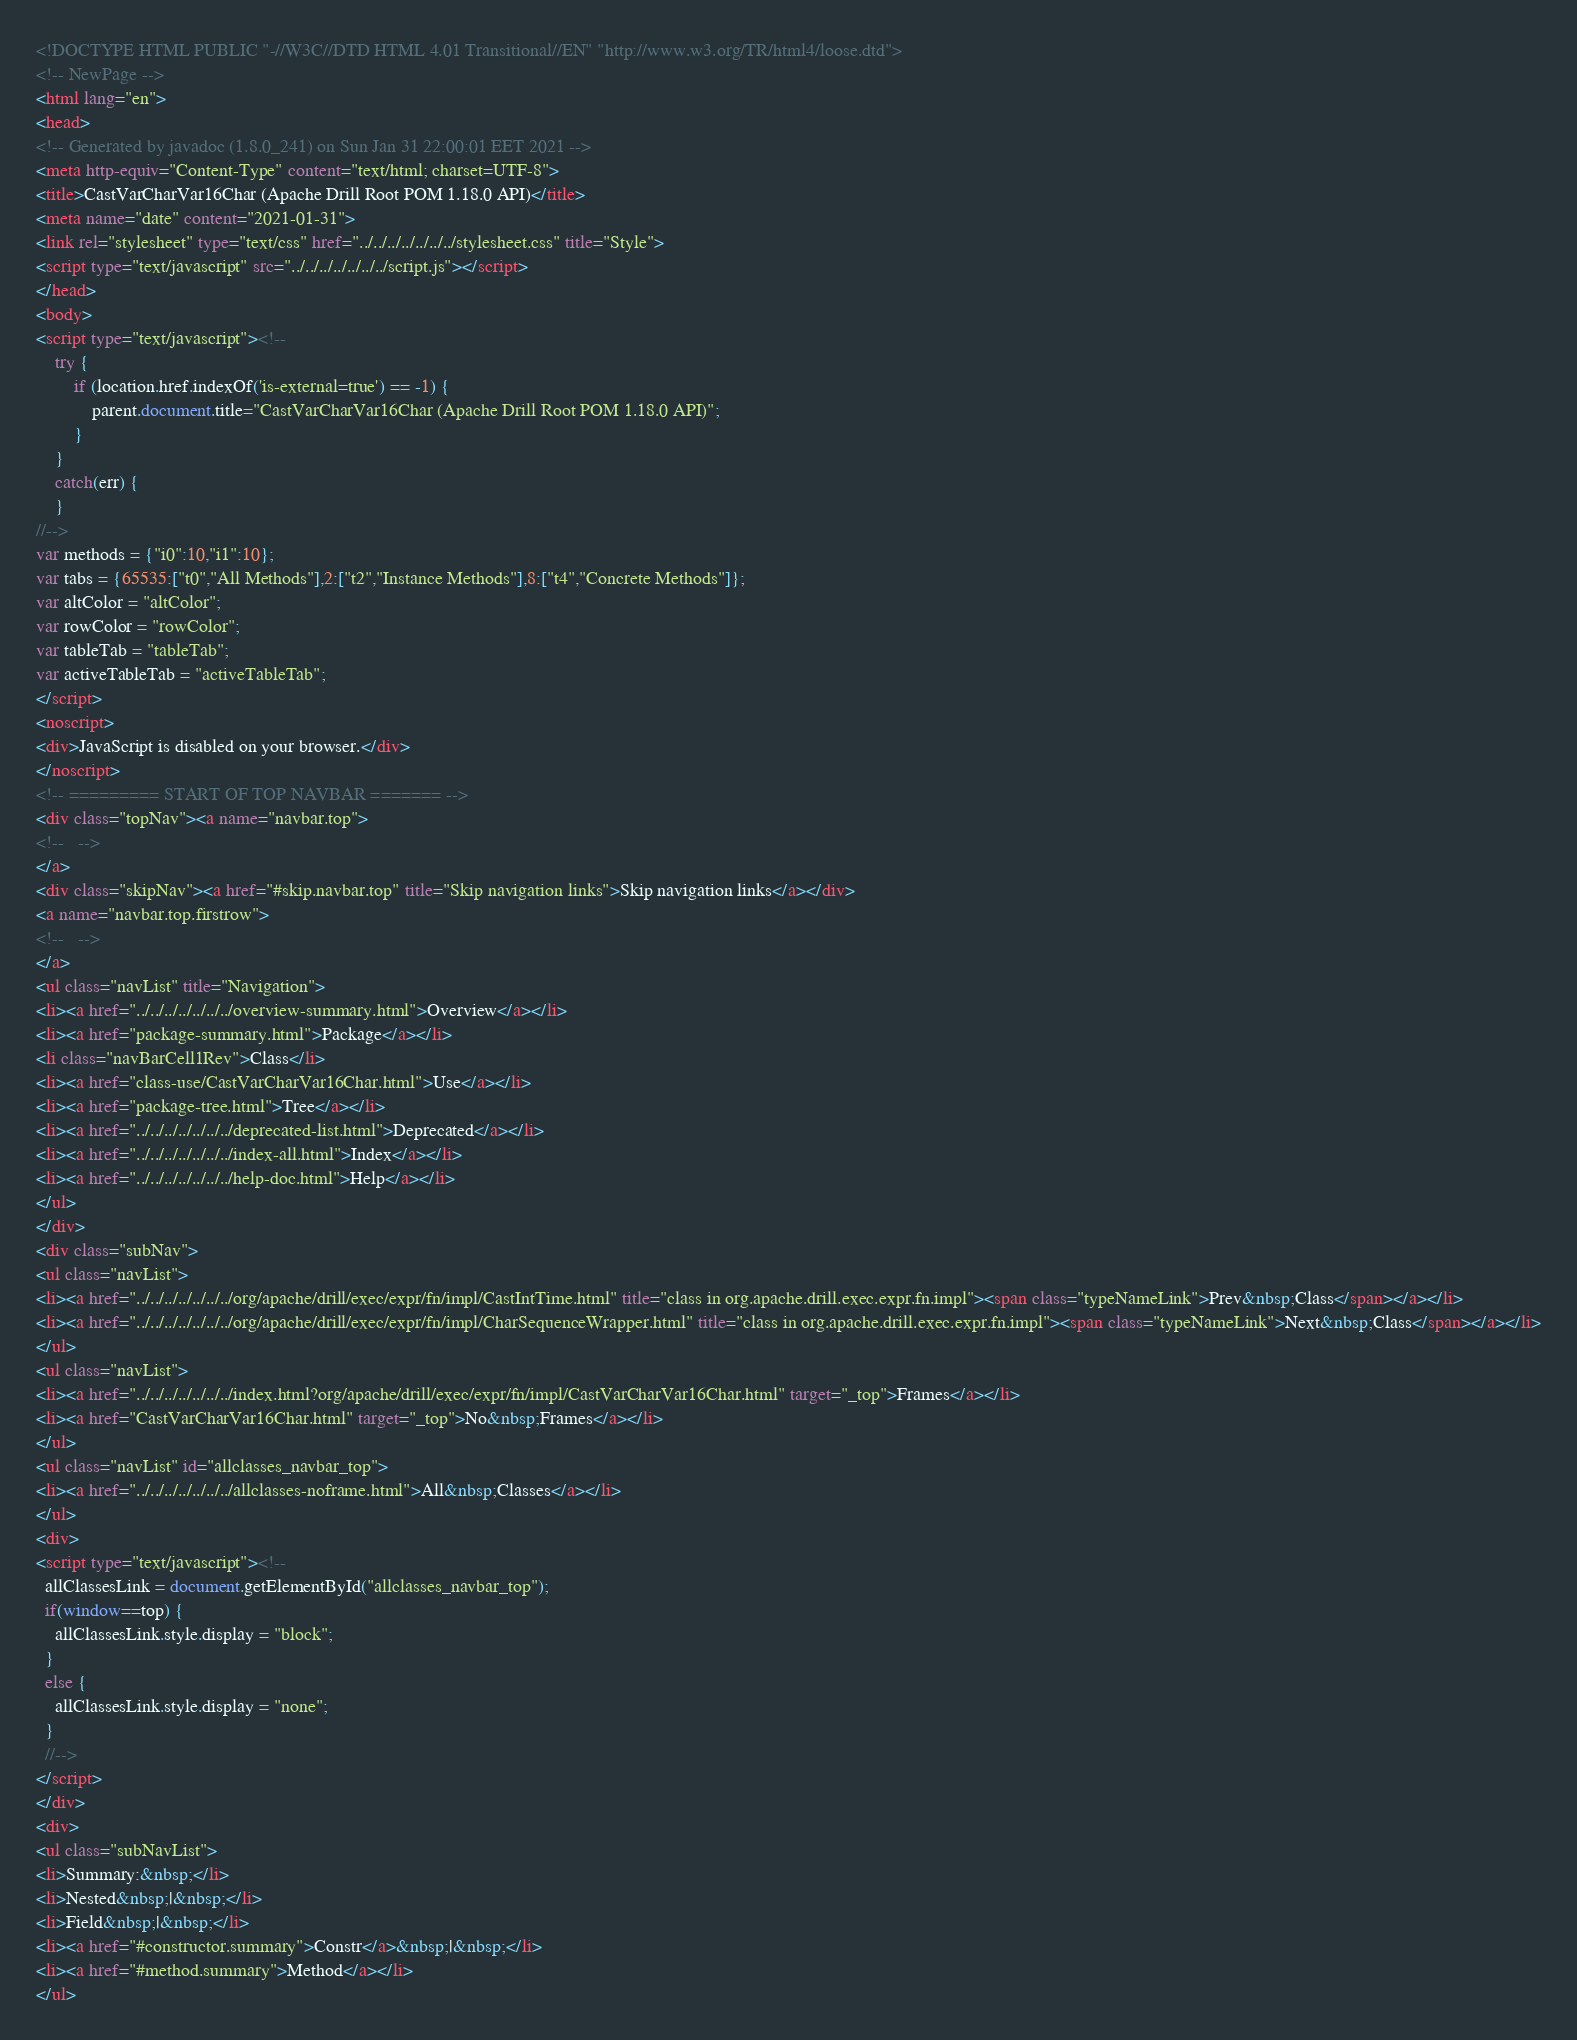Convert code to text. <code><loc_0><loc_0><loc_500><loc_500><_HTML_><!DOCTYPE HTML PUBLIC "-//W3C//DTD HTML 4.01 Transitional//EN" "http://www.w3.org/TR/html4/loose.dtd">
<!-- NewPage -->
<html lang="en">
<head>
<!-- Generated by javadoc (1.8.0_241) on Sun Jan 31 22:00:01 EET 2021 -->
<meta http-equiv="Content-Type" content="text/html; charset=UTF-8">
<title>CastVarCharVar16Char (Apache Drill Root POM 1.18.0 API)</title>
<meta name="date" content="2021-01-31">
<link rel="stylesheet" type="text/css" href="../../../../../../../stylesheet.css" title="Style">
<script type="text/javascript" src="../../../../../../../script.js"></script>
</head>
<body>
<script type="text/javascript"><!--
    try {
        if (location.href.indexOf('is-external=true') == -1) {
            parent.document.title="CastVarCharVar16Char (Apache Drill Root POM 1.18.0 API)";
        }
    }
    catch(err) {
    }
//-->
var methods = {"i0":10,"i1":10};
var tabs = {65535:["t0","All Methods"],2:["t2","Instance Methods"],8:["t4","Concrete Methods"]};
var altColor = "altColor";
var rowColor = "rowColor";
var tableTab = "tableTab";
var activeTableTab = "activeTableTab";
</script>
<noscript>
<div>JavaScript is disabled on your browser.</div>
</noscript>
<!-- ========= START OF TOP NAVBAR ======= -->
<div class="topNav"><a name="navbar.top">
<!--   -->
</a>
<div class="skipNav"><a href="#skip.navbar.top" title="Skip navigation links">Skip navigation links</a></div>
<a name="navbar.top.firstrow">
<!--   -->
</a>
<ul class="navList" title="Navigation">
<li><a href="../../../../../../../overview-summary.html">Overview</a></li>
<li><a href="package-summary.html">Package</a></li>
<li class="navBarCell1Rev">Class</li>
<li><a href="class-use/CastVarCharVar16Char.html">Use</a></li>
<li><a href="package-tree.html">Tree</a></li>
<li><a href="../../../../../../../deprecated-list.html">Deprecated</a></li>
<li><a href="../../../../../../../index-all.html">Index</a></li>
<li><a href="../../../../../../../help-doc.html">Help</a></li>
</ul>
</div>
<div class="subNav">
<ul class="navList">
<li><a href="../../../../../../../org/apache/drill/exec/expr/fn/impl/CastIntTime.html" title="class in org.apache.drill.exec.expr.fn.impl"><span class="typeNameLink">Prev&nbsp;Class</span></a></li>
<li><a href="../../../../../../../org/apache/drill/exec/expr/fn/impl/CharSequenceWrapper.html" title="class in org.apache.drill.exec.expr.fn.impl"><span class="typeNameLink">Next&nbsp;Class</span></a></li>
</ul>
<ul class="navList">
<li><a href="../../../../../../../index.html?org/apache/drill/exec/expr/fn/impl/CastVarCharVar16Char.html" target="_top">Frames</a></li>
<li><a href="CastVarCharVar16Char.html" target="_top">No&nbsp;Frames</a></li>
</ul>
<ul class="navList" id="allclasses_navbar_top">
<li><a href="../../../../../../../allclasses-noframe.html">All&nbsp;Classes</a></li>
</ul>
<div>
<script type="text/javascript"><!--
  allClassesLink = document.getElementById("allclasses_navbar_top");
  if(window==top) {
    allClassesLink.style.display = "block";
  }
  else {
    allClassesLink.style.display = "none";
  }
  //-->
</script>
</div>
<div>
<ul class="subNavList">
<li>Summary:&nbsp;</li>
<li>Nested&nbsp;|&nbsp;</li>
<li>Field&nbsp;|&nbsp;</li>
<li><a href="#constructor.summary">Constr</a>&nbsp;|&nbsp;</li>
<li><a href="#method.summary">Method</a></li>
</ul></code> 